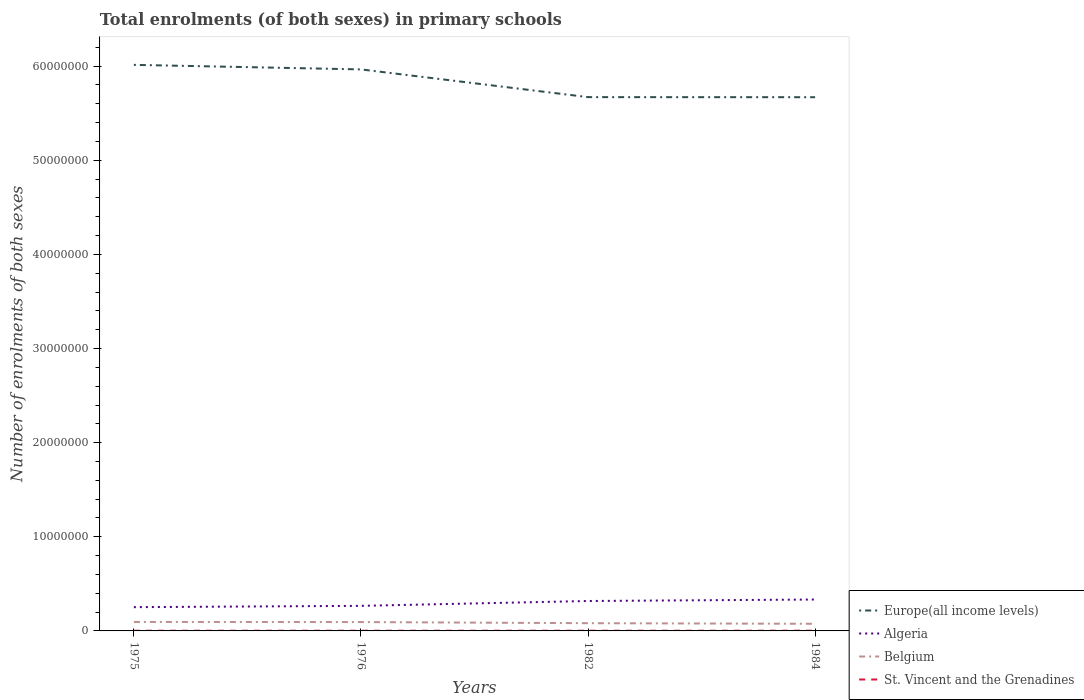Does the line corresponding to Algeria intersect with the line corresponding to Belgium?
Your response must be concise. No. Across all years, what is the maximum number of enrolments in primary schools in Algeria?
Your answer should be very brief. 2.53e+06. In which year was the number of enrolments in primary schools in Algeria maximum?
Provide a short and direct response. 1975. What is the total number of enrolments in primary schools in Belgium in the graph?
Give a very brief answer. 1.97e+05. What is the difference between the highest and the second highest number of enrolments in primary schools in Algeria?
Your answer should be very brief. 8.11e+05. What is the difference between two consecutive major ticks on the Y-axis?
Your answer should be very brief. 1.00e+07. Are the values on the major ticks of Y-axis written in scientific E-notation?
Your response must be concise. No. Does the graph contain any zero values?
Your response must be concise. No. Does the graph contain grids?
Keep it short and to the point. No. Where does the legend appear in the graph?
Offer a very short reply. Bottom right. How are the legend labels stacked?
Your response must be concise. Vertical. What is the title of the graph?
Make the answer very short. Total enrolments (of both sexes) in primary schools. Does "Bhutan" appear as one of the legend labels in the graph?
Provide a short and direct response. No. What is the label or title of the X-axis?
Provide a succinct answer. Years. What is the label or title of the Y-axis?
Ensure brevity in your answer.  Number of enrolments of both sexes. What is the Number of enrolments of both sexes of Europe(all income levels) in 1975?
Make the answer very short. 6.01e+07. What is the Number of enrolments of both sexes in Algeria in 1975?
Offer a terse response. 2.53e+06. What is the Number of enrolments of both sexes of Belgium in 1975?
Give a very brief answer. 9.55e+05. What is the Number of enrolments of both sexes in St. Vincent and the Grenadines in 1975?
Provide a succinct answer. 2.07e+04. What is the Number of enrolments of both sexes of Europe(all income levels) in 1976?
Offer a very short reply. 5.97e+07. What is the Number of enrolments of both sexes of Algeria in 1976?
Give a very brief answer. 2.66e+06. What is the Number of enrolments of both sexes in Belgium in 1976?
Your answer should be very brief. 9.42e+05. What is the Number of enrolments of both sexes of St. Vincent and the Grenadines in 1976?
Offer a very short reply. 2.19e+04. What is the Number of enrolments of both sexes in Europe(all income levels) in 1982?
Make the answer very short. 5.67e+07. What is the Number of enrolments of both sexes of Algeria in 1982?
Your answer should be very brief. 3.18e+06. What is the Number of enrolments of both sexes in Belgium in 1982?
Your answer should be compact. 8.21e+05. What is the Number of enrolments of both sexes of St. Vincent and the Grenadines in 1982?
Keep it short and to the point. 2.15e+04. What is the Number of enrolments of both sexes of Europe(all income levels) in 1984?
Provide a succinct answer. 5.67e+07. What is the Number of enrolments of both sexes in Algeria in 1984?
Give a very brief answer. 3.34e+06. What is the Number of enrolments of both sexes in Belgium in 1984?
Offer a very short reply. 7.59e+05. What is the Number of enrolments of both sexes in St. Vincent and the Grenadines in 1984?
Offer a terse response. 2.25e+04. Across all years, what is the maximum Number of enrolments of both sexes in Europe(all income levels)?
Your response must be concise. 6.01e+07. Across all years, what is the maximum Number of enrolments of both sexes of Algeria?
Your response must be concise. 3.34e+06. Across all years, what is the maximum Number of enrolments of both sexes of Belgium?
Your answer should be compact. 9.55e+05. Across all years, what is the maximum Number of enrolments of both sexes of St. Vincent and the Grenadines?
Make the answer very short. 2.25e+04. Across all years, what is the minimum Number of enrolments of both sexes of Europe(all income levels)?
Offer a terse response. 5.67e+07. Across all years, what is the minimum Number of enrolments of both sexes in Algeria?
Offer a terse response. 2.53e+06. Across all years, what is the minimum Number of enrolments of both sexes in Belgium?
Keep it short and to the point. 7.59e+05. Across all years, what is the minimum Number of enrolments of both sexes of St. Vincent and the Grenadines?
Offer a terse response. 2.07e+04. What is the total Number of enrolments of both sexes of Europe(all income levels) in the graph?
Provide a succinct answer. 2.33e+08. What is the total Number of enrolments of both sexes in Algeria in the graph?
Provide a short and direct response. 1.17e+07. What is the total Number of enrolments of both sexes in Belgium in the graph?
Your answer should be compact. 3.48e+06. What is the total Number of enrolments of both sexes in St. Vincent and the Grenadines in the graph?
Your response must be concise. 8.65e+04. What is the difference between the Number of enrolments of both sexes in Europe(all income levels) in 1975 and that in 1976?
Your response must be concise. 4.81e+05. What is the difference between the Number of enrolments of both sexes of Algeria in 1975 and that in 1976?
Your response must be concise. -1.38e+05. What is the difference between the Number of enrolments of both sexes of Belgium in 1975 and that in 1976?
Offer a very short reply. 1.33e+04. What is the difference between the Number of enrolments of both sexes of St. Vincent and the Grenadines in 1975 and that in 1976?
Ensure brevity in your answer.  -1130. What is the difference between the Number of enrolments of both sexes of Europe(all income levels) in 1975 and that in 1982?
Make the answer very short. 3.43e+06. What is the difference between the Number of enrolments of both sexes in Algeria in 1975 and that in 1982?
Your answer should be compact. -6.54e+05. What is the difference between the Number of enrolments of both sexes of Belgium in 1975 and that in 1982?
Ensure brevity in your answer.  1.34e+05. What is the difference between the Number of enrolments of both sexes in St. Vincent and the Grenadines in 1975 and that in 1982?
Offer a terse response. -773. What is the difference between the Number of enrolments of both sexes in Europe(all income levels) in 1975 and that in 1984?
Keep it short and to the point. 3.44e+06. What is the difference between the Number of enrolments of both sexes in Algeria in 1975 and that in 1984?
Keep it short and to the point. -8.11e+05. What is the difference between the Number of enrolments of both sexes in Belgium in 1975 and that in 1984?
Provide a short and direct response. 1.97e+05. What is the difference between the Number of enrolments of both sexes of St. Vincent and the Grenadines in 1975 and that in 1984?
Provide a short and direct response. -1730. What is the difference between the Number of enrolments of both sexes of Europe(all income levels) in 1976 and that in 1982?
Offer a very short reply. 2.95e+06. What is the difference between the Number of enrolments of both sexes of Algeria in 1976 and that in 1982?
Provide a succinct answer. -5.16e+05. What is the difference between the Number of enrolments of both sexes of Belgium in 1976 and that in 1982?
Give a very brief answer. 1.21e+05. What is the difference between the Number of enrolments of both sexes in St. Vincent and the Grenadines in 1976 and that in 1982?
Your response must be concise. 357. What is the difference between the Number of enrolments of both sexes of Europe(all income levels) in 1976 and that in 1984?
Ensure brevity in your answer.  2.95e+06. What is the difference between the Number of enrolments of both sexes of Algeria in 1976 and that in 1984?
Make the answer very short. -6.73e+05. What is the difference between the Number of enrolments of both sexes of Belgium in 1976 and that in 1984?
Offer a very short reply. 1.83e+05. What is the difference between the Number of enrolments of both sexes of St. Vincent and the Grenadines in 1976 and that in 1984?
Provide a succinct answer. -600. What is the difference between the Number of enrolments of both sexes in Europe(all income levels) in 1982 and that in 1984?
Provide a short and direct response. 8120. What is the difference between the Number of enrolments of both sexes of Algeria in 1982 and that in 1984?
Provide a succinct answer. -1.58e+05. What is the difference between the Number of enrolments of both sexes of Belgium in 1982 and that in 1984?
Your response must be concise. 6.24e+04. What is the difference between the Number of enrolments of both sexes of St. Vincent and the Grenadines in 1982 and that in 1984?
Offer a very short reply. -957. What is the difference between the Number of enrolments of both sexes in Europe(all income levels) in 1975 and the Number of enrolments of both sexes in Algeria in 1976?
Ensure brevity in your answer.  5.75e+07. What is the difference between the Number of enrolments of both sexes of Europe(all income levels) in 1975 and the Number of enrolments of both sexes of Belgium in 1976?
Keep it short and to the point. 5.92e+07. What is the difference between the Number of enrolments of both sexes in Europe(all income levels) in 1975 and the Number of enrolments of both sexes in St. Vincent and the Grenadines in 1976?
Your answer should be compact. 6.01e+07. What is the difference between the Number of enrolments of both sexes in Algeria in 1975 and the Number of enrolments of both sexes in Belgium in 1976?
Your answer should be compact. 1.58e+06. What is the difference between the Number of enrolments of both sexes in Algeria in 1975 and the Number of enrolments of both sexes in St. Vincent and the Grenadines in 1976?
Your response must be concise. 2.50e+06. What is the difference between the Number of enrolments of both sexes in Belgium in 1975 and the Number of enrolments of both sexes in St. Vincent and the Grenadines in 1976?
Your answer should be very brief. 9.33e+05. What is the difference between the Number of enrolments of both sexes of Europe(all income levels) in 1975 and the Number of enrolments of both sexes of Algeria in 1982?
Your answer should be very brief. 5.70e+07. What is the difference between the Number of enrolments of both sexes of Europe(all income levels) in 1975 and the Number of enrolments of both sexes of Belgium in 1982?
Offer a terse response. 5.93e+07. What is the difference between the Number of enrolments of both sexes in Europe(all income levels) in 1975 and the Number of enrolments of both sexes in St. Vincent and the Grenadines in 1982?
Offer a very short reply. 6.01e+07. What is the difference between the Number of enrolments of both sexes of Algeria in 1975 and the Number of enrolments of both sexes of Belgium in 1982?
Provide a succinct answer. 1.70e+06. What is the difference between the Number of enrolments of both sexes of Algeria in 1975 and the Number of enrolments of both sexes of St. Vincent and the Grenadines in 1982?
Ensure brevity in your answer.  2.50e+06. What is the difference between the Number of enrolments of both sexes of Belgium in 1975 and the Number of enrolments of both sexes of St. Vincent and the Grenadines in 1982?
Your response must be concise. 9.34e+05. What is the difference between the Number of enrolments of both sexes in Europe(all income levels) in 1975 and the Number of enrolments of both sexes in Algeria in 1984?
Make the answer very short. 5.68e+07. What is the difference between the Number of enrolments of both sexes in Europe(all income levels) in 1975 and the Number of enrolments of both sexes in Belgium in 1984?
Keep it short and to the point. 5.94e+07. What is the difference between the Number of enrolments of both sexes in Europe(all income levels) in 1975 and the Number of enrolments of both sexes in St. Vincent and the Grenadines in 1984?
Keep it short and to the point. 6.01e+07. What is the difference between the Number of enrolments of both sexes of Algeria in 1975 and the Number of enrolments of both sexes of Belgium in 1984?
Your answer should be compact. 1.77e+06. What is the difference between the Number of enrolments of both sexes in Algeria in 1975 and the Number of enrolments of both sexes in St. Vincent and the Grenadines in 1984?
Your answer should be very brief. 2.50e+06. What is the difference between the Number of enrolments of both sexes of Belgium in 1975 and the Number of enrolments of both sexes of St. Vincent and the Grenadines in 1984?
Your answer should be compact. 9.33e+05. What is the difference between the Number of enrolments of both sexes of Europe(all income levels) in 1976 and the Number of enrolments of both sexes of Algeria in 1982?
Make the answer very short. 5.65e+07. What is the difference between the Number of enrolments of both sexes of Europe(all income levels) in 1976 and the Number of enrolments of both sexes of Belgium in 1982?
Keep it short and to the point. 5.88e+07. What is the difference between the Number of enrolments of both sexes of Europe(all income levels) in 1976 and the Number of enrolments of both sexes of St. Vincent and the Grenadines in 1982?
Your response must be concise. 5.96e+07. What is the difference between the Number of enrolments of both sexes of Algeria in 1976 and the Number of enrolments of both sexes of Belgium in 1982?
Give a very brief answer. 1.84e+06. What is the difference between the Number of enrolments of both sexes of Algeria in 1976 and the Number of enrolments of both sexes of St. Vincent and the Grenadines in 1982?
Keep it short and to the point. 2.64e+06. What is the difference between the Number of enrolments of both sexes in Belgium in 1976 and the Number of enrolments of both sexes in St. Vincent and the Grenadines in 1982?
Make the answer very short. 9.20e+05. What is the difference between the Number of enrolments of both sexes of Europe(all income levels) in 1976 and the Number of enrolments of both sexes of Algeria in 1984?
Your response must be concise. 5.63e+07. What is the difference between the Number of enrolments of both sexes in Europe(all income levels) in 1976 and the Number of enrolments of both sexes in Belgium in 1984?
Your response must be concise. 5.89e+07. What is the difference between the Number of enrolments of both sexes in Europe(all income levels) in 1976 and the Number of enrolments of both sexes in St. Vincent and the Grenadines in 1984?
Your answer should be very brief. 5.96e+07. What is the difference between the Number of enrolments of both sexes in Algeria in 1976 and the Number of enrolments of both sexes in Belgium in 1984?
Offer a very short reply. 1.90e+06. What is the difference between the Number of enrolments of both sexes of Algeria in 1976 and the Number of enrolments of both sexes of St. Vincent and the Grenadines in 1984?
Give a very brief answer. 2.64e+06. What is the difference between the Number of enrolments of both sexes of Belgium in 1976 and the Number of enrolments of both sexes of St. Vincent and the Grenadines in 1984?
Your answer should be very brief. 9.19e+05. What is the difference between the Number of enrolments of both sexes in Europe(all income levels) in 1982 and the Number of enrolments of both sexes in Algeria in 1984?
Keep it short and to the point. 5.34e+07. What is the difference between the Number of enrolments of both sexes in Europe(all income levels) in 1982 and the Number of enrolments of both sexes in Belgium in 1984?
Provide a succinct answer. 5.60e+07. What is the difference between the Number of enrolments of both sexes of Europe(all income levels) in 1982 and the Number of enrolments of both sexes of St. Vincent and the Grenadines in 1984?
Your response must be concise. 5.67e+07. What is the difference between the Number of enrolments of both sexes in Algeria in 1982 and the Number of enrolments of both sexes in Belgium in 1984?
Offer a very short reply. 2.42e+06. What is the difference between the Number of enrolments of both sexes of Algeria in 1982 and the Number of enrolments of both sexes of St. Vincent and the Grenadines in 1984?
Your answer should be very brief. 3.16e+06. What is the difference between the Number of enrolments of both sexes in Belgium in 1982 and the Number of enrolments of both sexes in St. Vincent and the Grenadines in 1984?
Your response must be concise. 7.99e+05. What is the average Number of enrolments of both sexes in Europe(all income levels) per year?
Provide a short and direct response. 5.83e+07. What is the average Number of enrolments of both sexes of Algeria per year?
Make the answer very short. 2.93e+06. What is the average Number of enrolments of both sexes of Belgium per year?
Your response must be concise. 8.69e+05. What is the average Number of enrolments of both sexes in St. Vincent and the Grenadines per year?
Give a very brief answer. 2.16e+04. In the year 1975, what is the difference between the Number of enrolments of both sexes in Europe(all income levels) and Number of enrolments of both sexes in Algeria?
Your response must be concise. 5.76e+07. In the year 1975, what is the difference between the Number of enrolments of both sexes of Europe(all income levels) and Number of enrolments of both sexes of Belgium?
Provide a succinct answer. 5.92e+07. In the year 1975, what is the difference between the Number of enrolments of both sexes in Europe(all income levels) and Number of enrolments of both sexes in St. Vincent and the Grenadines?
Give a very brief answer. 6.01e+07. In the year 1975, what is the difference between the Number of enrolments of both sexes of Algeria and Number of enrolments of both sexes of Belgium?
Give a very brief answer. 1.57e+06. In the year 1975, what is the difference between the Number of enrolments of both sexes in Algeria and Number of enrolments of both sexes in St. Vincent and the Grenadines?
Provide a short and direct response. 2.50e+06. In the year 1975, what is the difference between the Number of enrolments of both sexes in Belgium and Number of enrolments of both sexes in St. Vincent and the Grenadines?
Offer a terse response. 9.35e+05. In the year 1976, what is the difference between the Number of enrolments of both sexes in Europe(all income levels) and Number of enrolments of both sexes in Algeria?
Offer a very short reply. 5.70e+07. In the year 1976, what is the difference between the Number of enrolments of both sexes in Europe(all income levels) and Number of enrolments of both sexes in Belgium?
Ensure brevity in your answer.  5.87e+07. In the year 1976, what is the difference between the Number of enrolments of both sexes of Europe(all income levels) and Number of enrolments of both sexes of St. Vincent and the Grenadines?
Ensure brevity in your answer.  5.96e+07. In the year 1976, what is the difference between the Number of enrolments of both sexes in Algeria and Number of enrolments of both sexes in Belgium?
Give a very brief answer. 1.72e+06. In the year 1976, what is the difference between the Number of enrolments of both sexes in Algeria and Number of enrolments of both sexes in St. Vincent and the Grenadines?
Your answer should be compact. 2.64e+06. In the year 1976, what is the difference between the Number of enrolments of both sexes in Belgium and Number of enrolments of both sexes in St. Vincent and the Grenadines?
Make the answer very short. 9.20e+05. In the year 1982, what is the difference between the Number of enrolments of both sexes of Europe(all income levels) and Number of enrolments of both sexes of Algeria?
Your answer should be compact. 5.35e+07. In the year 1982, what is the difference between the Number of enrolments of both sexes of Europe(all income levels) and Number of enrolments of both sexes of Belgium?
Your answer should be compact. 5.59e+07. In the year 1982, what is the difference between the Number of enrolments of both sexes in Europe(all income levels) and Number of enrolments of both sexes in St. Vincent and the Grenadines?
Provide a short and direct response. 5.67e+07. In the year 1982, what is the difference between the Number of enrolments of both sexes in Algeria and Number of enrolments of both sexes in Belgium?
Give a very brief answer. 2.36e+06. In the year 1982, what is the difference between the Number of enrolments of both sexes of Algeria and Number of enrolments of both sexes of St. Vincent and the Grenadines?
Keep it short and to the point. 3.16e+06. In the year 1982, what is the difference between the Number of enrolments of both sexes in Belgium and Number of enrolments of both sexes in St. Vincent and the Grenadines?
Offer a very short reply. 8.00e+05. In the year 1984, what is the difference between the Number of enrolments of both sexes of Europe(all income levels) and Number of enrolments of both sexes of Algeria?
Offer a very short reply. 5.34e+07. In the year 1984, what is the difference between the Number of enrolments of both sexes in Europe(all income levels) and Number of enrolments of both sexes in Belgium?
Offer a very short reply. 5.59e+07. In the year 1984, what is the difference between the Number of enrolments of both sexes of Europe(all income levels) and Number of enrolments of both sexes of St. Vincent and the Grenadines?
Ensure brevity in your answer.  5.67e+07. In the year 1984, what is the difference between the Number of enrolments of both sexes in Algeria and Number of enrolments of both sexes in Belgium?
Provide a short and direct response. 2.58e+06. In the year 1984, what is the difference between the Number of enrolments of both sexes in Algeria and Number of enrolments of both sexes in St. Vincent and the Grenadines?
Offer a very short reply. 3.31e+06. In the year 1984, what is the difference between the Number of enrolments of both sexes of Belgium and Number of enrolments of both sexes of St. Vincent and the Grenadines?
Make the answer very short. 7.36e+05. What is the ratio of the Number of enrolments of both sexes of Algeria in 1975 to that in 1976?
Provide a short and direct response. 0.95. What is the ratio of the Number of enrolments of both sexes in Belgium in 1975 to that in 1976?
Keep it short and to the point. 1.01. What is the ratio of the Number of enrolments of both sexes in St. Vincent and the Grenadines in 1975 to that in 1976?
Provide a succinct answer. 0.95. What is the ratio of the Number of enrolments of both sexes in Europe(all income levels) in 1975 to that in 1982?
Your answer should be very brief. 1.06. What is the ratio of the Number of enrolments of both sexes of Algeria in 1975 to that in 1982?
Provide a succinct answer. 0.79. What is the ratio of the Number of enrolments of both sexes in Belgium in 1975 to that in 1982?
Keep it short and to the point. 1.16. What is the ratio of the Number of enrolments of both sexes of St. Vincent and the Grenadines in 1975 to that in 1982?
Provide a short and direct response. 0.96. What is the ratio of the Number of enrolments of both sexes of Europe(all income levels) in 1975 to that in 1984?
Offer a very short reply. 1.06. What is the ratio of the Number of enrolments of both sexes in Algeria in 1975 to that in 1984?
Your answer should be very brief. 0.76. What is the ratio of the Number of enrolments of both sexes in Belgium in 1975 to that in 1984?
Provide a short and direct response. 1.26. What is the ratio of the Number of enrolments of both sexes in St. Vincent and the Grenadines in 1975 to that in 1984?
Offer a terse response. 0.92. What is the ratio of the Number of enrolments of both sexes in Europe(all income levels) in 1976 to that in 1982?
Make the answer very short. 1.05. What is the ratio of the Number of enrolments of both sexes of Algeria in 1976 to that in 1982?
Your response must be concise. 0.84. What is the ratio of the Number of enrolments of both sexes in Belgium in 1976 to that in 1982?
Provide a short and direct response. 1.15. What is the ratio of the Number of enrolments of both sexes in St. Vincent and the Grenadines in 1976 to that in 1982?
Offer a terse response. 1.02. What is the ratio of the Number of enrolments of both sexes of Europe(all income levels) in 1976 to that in 1984?
Provide a succinct answer. 1.05. What is the ratio of the Number of enrolments of both sexes of Algeria in 1976 to that in 1984?
Make the answer very short. 0.8. What is the ratio of the Number of enrolments of both sexes in Belgium in 1976 to that in 1984?
Ensure brevity in your answer.  1.24. What is the ratio of the Number of enrolments of both sexes of St. Vincent and the Grenadines in 1976 to that in 1984?
Offer a terse response. 0.97. What is the ratio of the Number of enrolments of both sexes in Europe(all income levels) in 1982 to that in 1984?
Ensure brevity in your answer.  1. What is the ratio of the Number of enrolments of both sexes in Algeria in 1982 to that in 1984?
Your response must be concise. 0.95. What is the ratio of the Number of enrolments of both sexes of Belgium in 1982 to that in 1984?
Your answer should be very brief. 1.08. What is the ratio of the Number of enrolments of both sexes in St. Vincent and the Grenadines in 1982 to that in 1984?
Provide a short and direct response. 0.96. What is the difference between the highest and the second highest Number of enrolments of both sexes in Europe(all income levels)?
Offer a very short reply. 4.81e+05. What is the difference between the highest and the second highest Number of enrolments of both sexes in Algeria?
Offer a terse response. 1.58e+05. What is the difference between the highest and the second highest Number of enrolments of both sexes in Belgium?
Ensure brevity in your answer.  1.33e+04. What is the difference between the highest and the second highest Number of enrolments of both sexes of St. Vincent and the Grenadines?
Ensure brevity in your answer.  600. What is the difference between the highest and the lowest Number of enrolments of both sexes in Europe(all income levels)?
Provide a short and direct response. 3.44e+06. What is the difference between the highest and the lowest Number of enrolments of both sexes of Algeria?
Your response must be concise. 8.11e+05. What is the difference between the highest and the lowest Number of enrolments of both sexes of Belgium?
Your answer should be compact. 1.97e+05. What is the difference between the highest and the lowest Number of enrolments of both sexes of St. Vincent and the Grenadines?
Make the answer very short. 1730. 